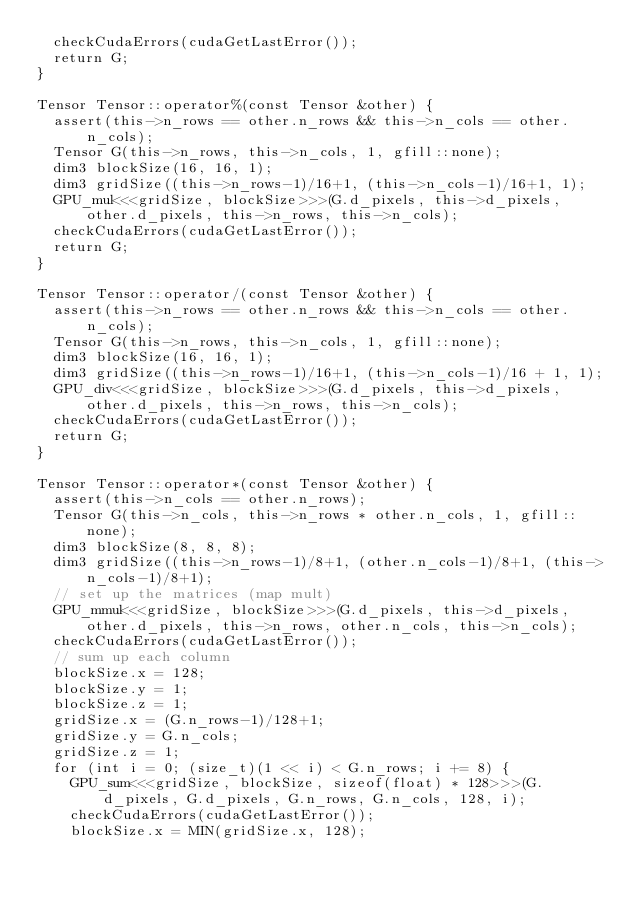<code> <loc_0><loc_0><loc_500><loc_500><_Cuda_>  checkCudaErrors(cudaGetLastError());
  return G;
}

Tensor Tensor::operator%(const Tensor &other) {
  assert(this->n_rows == other.n_rows && this->n_cols == other.n_cols);
  Tensor G(this->n_rows, this->n_cols, 1, gfill::none);
  dim3 blockSize(16, 16, 1);
  dim3 gridSize((this->n_rows-1)/16+1, (this->n_cols-1)/16+1, 1);
  GPU_mul<<<gridSize, blockSize>>>(G.d_pixels, this->d_pixels, other.d_pixels, this->n_rows, this->n_cols);
  checkCudaErrors(cudaGetLastError());
  return G;
}

Tensor Tensor::operator/(const Tensor &other) {
  assert(this->n_rows == other.n_rows && this->n_cols == other.n_cols);
  Tensor G(this->n_rows, this->n_cols, 1, gfill::none);
  dim3 blockSize(16, 16, 1);
  dim3 gridSize((this->n_rows-1)/16+1, (this->n_cols-1)/16 + 1, 1);
  GPU_div<<<gridSize, blockSize>>>(G.d_pixels, this->d_pixels, other.d_pixels, this->n_rows, this->n_cols);
  checkCudaErrors(cudaGetLastError());
  return G;
}

Tensor Tensor::operator*(const Tensor &other) {
  assert(this->n_cols == other.n_rows);
  Tensor G(this->n_cols, this->n_rows * other.n_cols, 1, gfill::none);
  dim3 blockSize(8, 8, 8);
  dim3 gridSize((this->n_rows-1)/8+1, (other.n_cols-1)/8+1, (this->n_cols-1)/8+1);
  // set up the matrices (map mult)
  GPU_mmul<<<gridSize, blockSize>>>(G.d_pixels, this->d_pixels, other.d_pixels, this->n_rows, other.n_cols, this->n_cols);
  checkCudaErrors(cudaGetLastError());
  // sum up each column
  blockSize.x = 128;
  blockSize.y = 1;
  blockSize.z = 1;
  gridSize.x = (G.n_rows-1)/128+1;
  gridSize.y = G.n_cols;
  gridSize.z = 1;
  for (int i = 0; (size_t)(1 << i) < G.n_rows; i += 8) {
    GPU_sum<<<gridSize, blockSize, sizeof(float) * 128>>>(G.d_pixels, G.d_pixels, G.n_rows, G.n_cols, 128, i);
    checkCudaErrors(cudaGetLastError());
    blockSize.x = MIN(gridSize.x, 128);</code> 